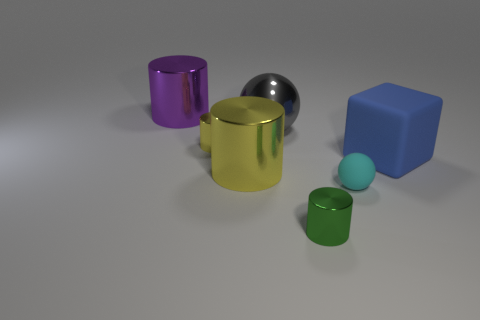What number of things are either purple spheres or yellow cylinders?
Offer a very short reply. 2. Are there any other things that are the same material as the purple cylinder?
Offer a terse response. Yes. Are any matte spheres visible?
Offer a very short reply. Yes. Is the cylinder that is in front of the small cyan ball made of the same material as the cyan thing?
Provide a short and direct response. No. Is there a blue thing of the same shape as the big yellow metallic thing?
Your answer should be very brief. No. Are there the same number of big gray metallic things that are left of the gray sphere and tiny matte spheres?
Provide a short and direct response. No. What is the large cylinder that is in front of the shiny cylinder that is on the left side of the small yellow shiny thing made of?
Keep it short and to the point. Metal. The purple metallic thing has what shape?
Provide a succinct answer. Cylinder. Is the number of tiny green metallic cylinders that are in front of the small green shiny thing the same as the number of tiny objects in front of the block?
Provide a succinct answer. No. There is a small object behind the tiny cyan object; is its color the same as the big metal cylinder in front of the large shiny sphere?
Your response must be concise. Yes. 